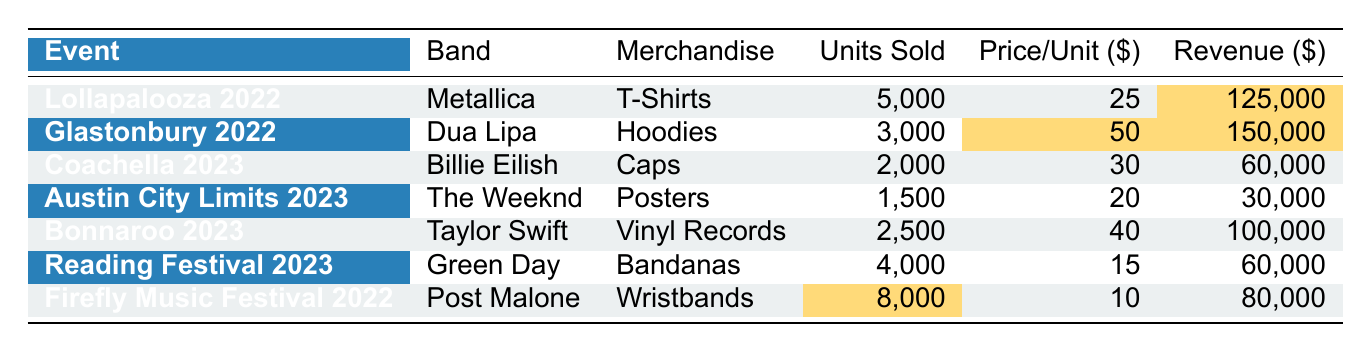What is the total revenue generated by merchandise sales at Lollapalooza 2022? The total revenue for Lollapalooza 2022 for T-Shirts is listed in the table as 125,000.
Answer: 125,000 Which band sold the most units of merchandise? Firefly Music Festival 2022 has 8,000 units of Wristbands sold by Post Malone, which is the highest compared to all other events listed.
Answer: Post Malone What is the revenue from selling vinyl records at Bonnaroo 2023? The table states that Taylor Swift sold vinyl records at Bonnaroo 2023 which generated a revenue of 100,000.
Answer: 100,000 What is the average price per unit across all merchandise types? To find the average, sum the price per unit: (25 + 50 + 30 + 20 + 40 + 15 + 10) = 190, then divide by the number of types (7): 190/7 ≈ 27.14.
Answer: 27.14 How much more revenue was generated at Glastonbury 2022 compared to Firefly Music Festival 2022? The revenue at Glastonbury 2022 is 150,000 and Firefly 2022 is 80,000. The difference is: 150,000 - 80,000 = 70,000.
Answer: 70,000 Did Green Day sell more units of merchandise than The Weeknd? Green Day sold 4,000 units while The Weeknd sold 1,500 units, thus Green Day sold more.
Answer: Yes Which event had the second highest total revenue? Revenue amounts are sorted: Lollapalooza 2022 $125,000, Glastonbury 2022 $150,000, and Bonnaroo 2023 $100,000; thus Glastonbury, 150,000 is the highest and Lollapalooza, 125,000 is second.
Answer: Lollapalooza 2022 What is the ratio of units sold for T-Shirts at Lollapalooza to Bandanas at Reading Festival? Lollapalooza sold 5,000 T-Shirts and Reading Festival sold 4,000 Bandanas. The ratio is 5000:4000, which simplifies to 5:4.
Answer: 5:4 Which merchandise type generated the maximum revenue? The highest revenue is 150,000 from Hoodies sold at Glastonbury 2022.
Answer: Hoodies Calculate the total units sold across all events. Add the units sold per event: 5000 + 3000 + 2000 + 1500 + 2500 + 4000 + 8000 = 21,000 units sold in total.
Answer: 21,000 